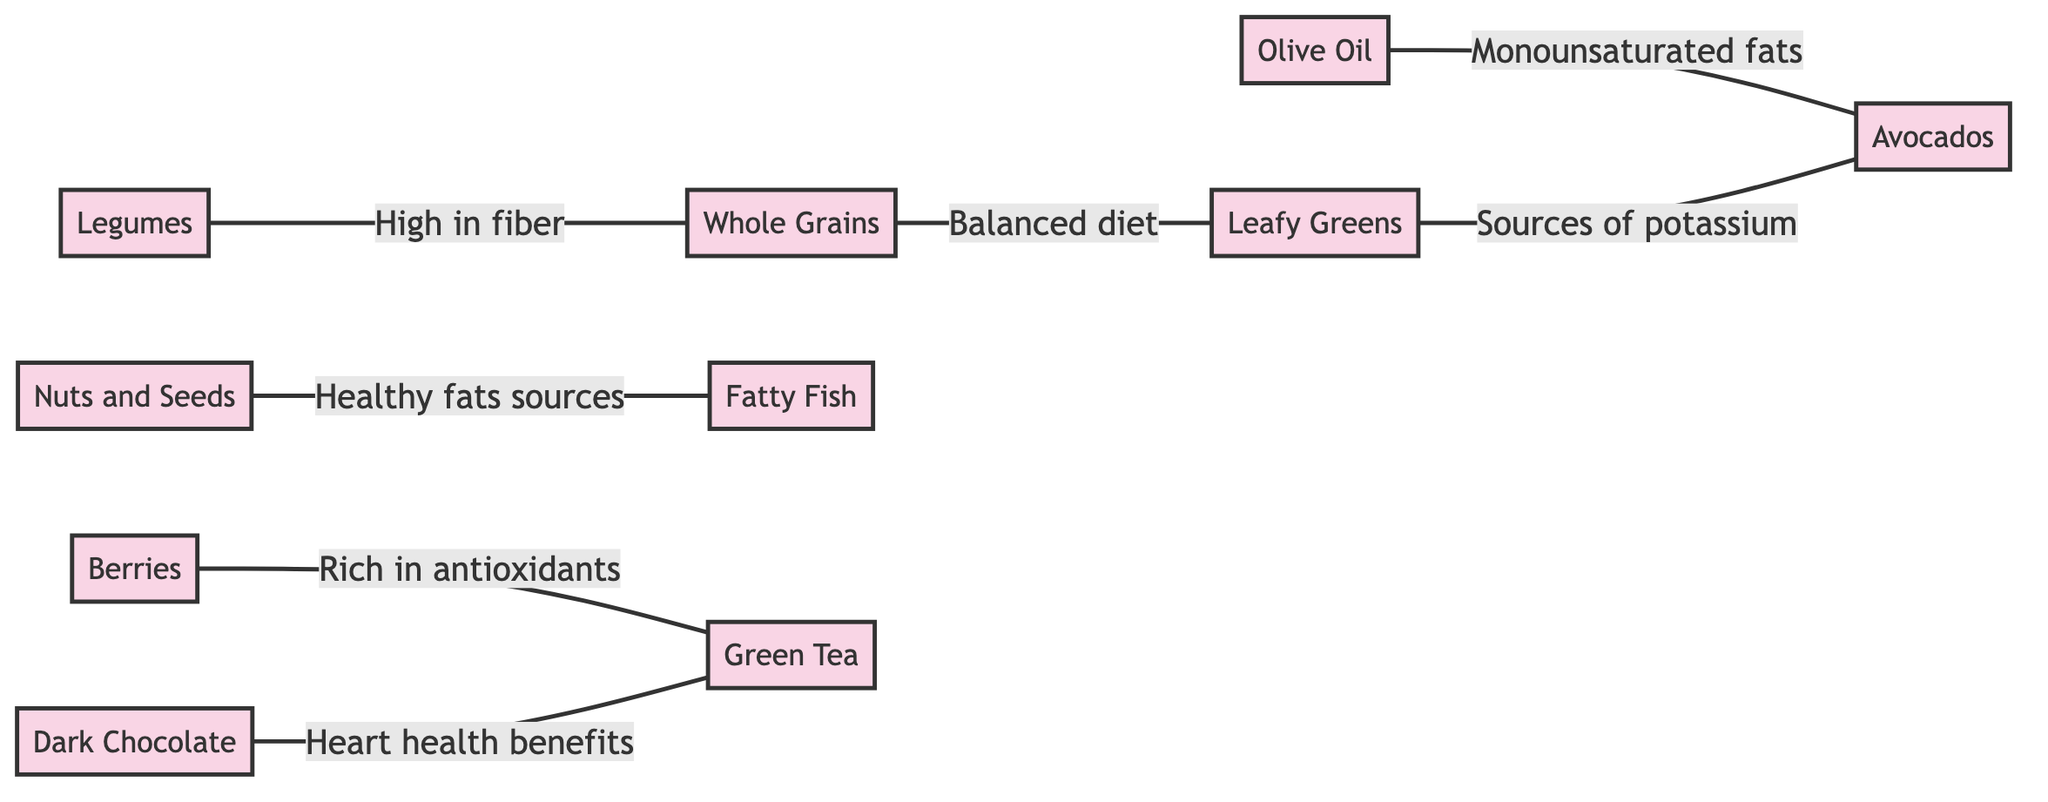What are the nutritional benefits of Whole Grains? Whole Grains has been listed with three nutritional benefits: Dietary Fiber, B Vitamins, and Iron. These benefits can be found directly associated with the Whole Grains node in the diagram.
Answer: Dietary Fiber, B Vitamins, Iron How many food groups are connected to Leafy Greens? By analyzing the diagram, Leafy Greens is connected to two food groups: Whole Grains and Avocados. This is determined by counting the connections shown in the diagram.
Answer: 2 What is the relationship between Nuts and Seeds and Fatty Fish? The relationship between Nuts and Seeds and Fatty Fish is labeled as "Healthy fats sources." This can be found in the connection indicated in the diagram.
Answer: Healthy fats sources Which food group has the effect of reducing bad cholesterol? Olive Oil and Nuts and Seeds are both mentioned as having the effect of reducing bad cholesterol (LDL). Olive Oil can be identified with this effect in the diagram as a direct link to its heart health impact.
Answer: Olive Oil, Nuts and Seeds Which two food groups are described as sources of potassium? The food groups described as sources of potassium are Legumes and Avocados. This information can be gathered from the connections in the diagram where Legumes is linked to Whole Grains, and Leafy Greens is also linked to Avocados.
Answer: Legumes, Avocados How does Dark Chocolate contribute to heart health? Dark Chocolate is indicated to improve blood flow and lower blood pressure as per the description associated with this node in the diagram. The specific wording is presented directly within its node.
Answer: Improve blood flow and lower blood pressure What is the main shared nutritional benefit between Berries and Green Tea? The main shared nutritional benefit between Berries and Green Tea is antioxidants. This can be deduced from the connections that highlight both food groups' rich antioxidant properties.
Answer: Antioxidants How many connections originate from Olive Oil? Olive Oil has one direct connection, which is to Avocados as indicated in the diagram. By counting the outgoing edges from the Olive Oil node, we can confirm this.
Answer: 1 What is the impact of Fatty Fish on heart health? The impact of Fatty Fish on heart health is to reduce the risk of arrhythmias and lower blood pressure. This information is explicitly provided within the node for Fatty Fish in the diagram.
Answer: Reduce risk of arrhythmias and lower blood pressure 